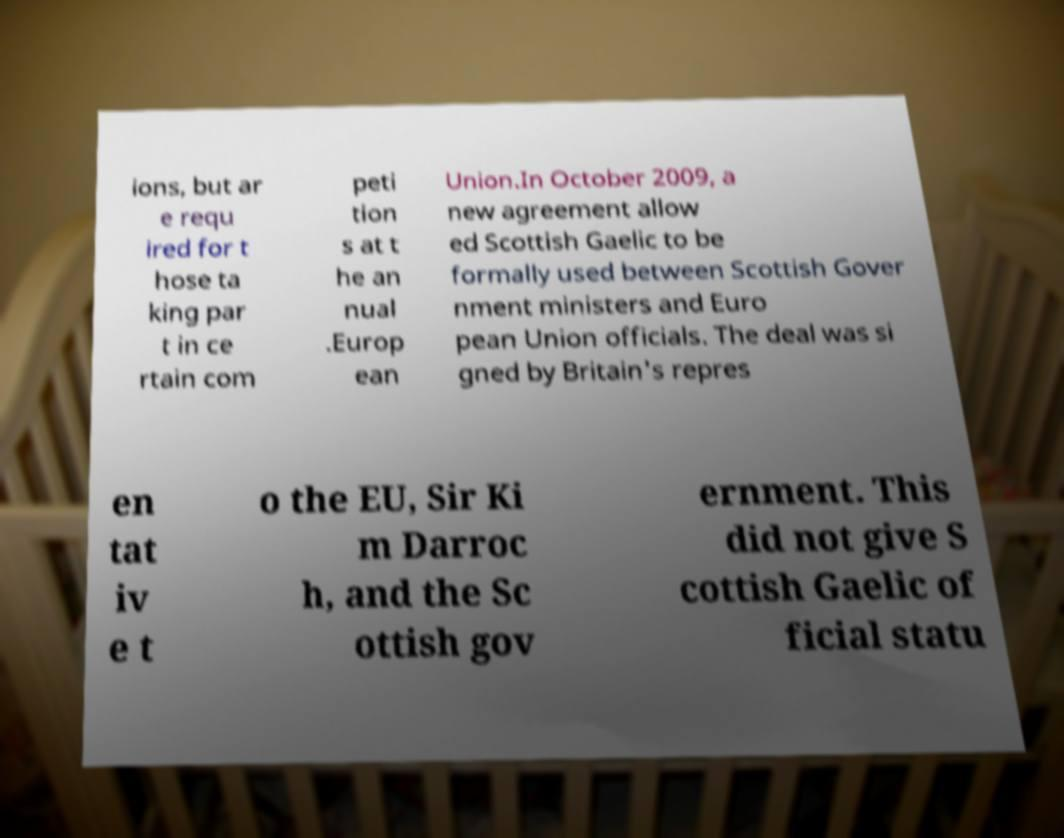Could you assist in decoding the text presented in this image and type it out clearly? ions, but ar e requ ired for t hose ta king par t in ce rtain com peti tion s at t he an nual .Europ ean Union.In October 2009, a new agreement allow ed Scottish Gaelic to be formally used between Scottish Gover nment ministers and Euro pean Union officials. The deal was si gned by Britain's repres en tat iv e t o the EU, Sir Ki m Darroc h, and the Sc ottish gov ernment. This did not give S cottish Gaelic of ficial statu 